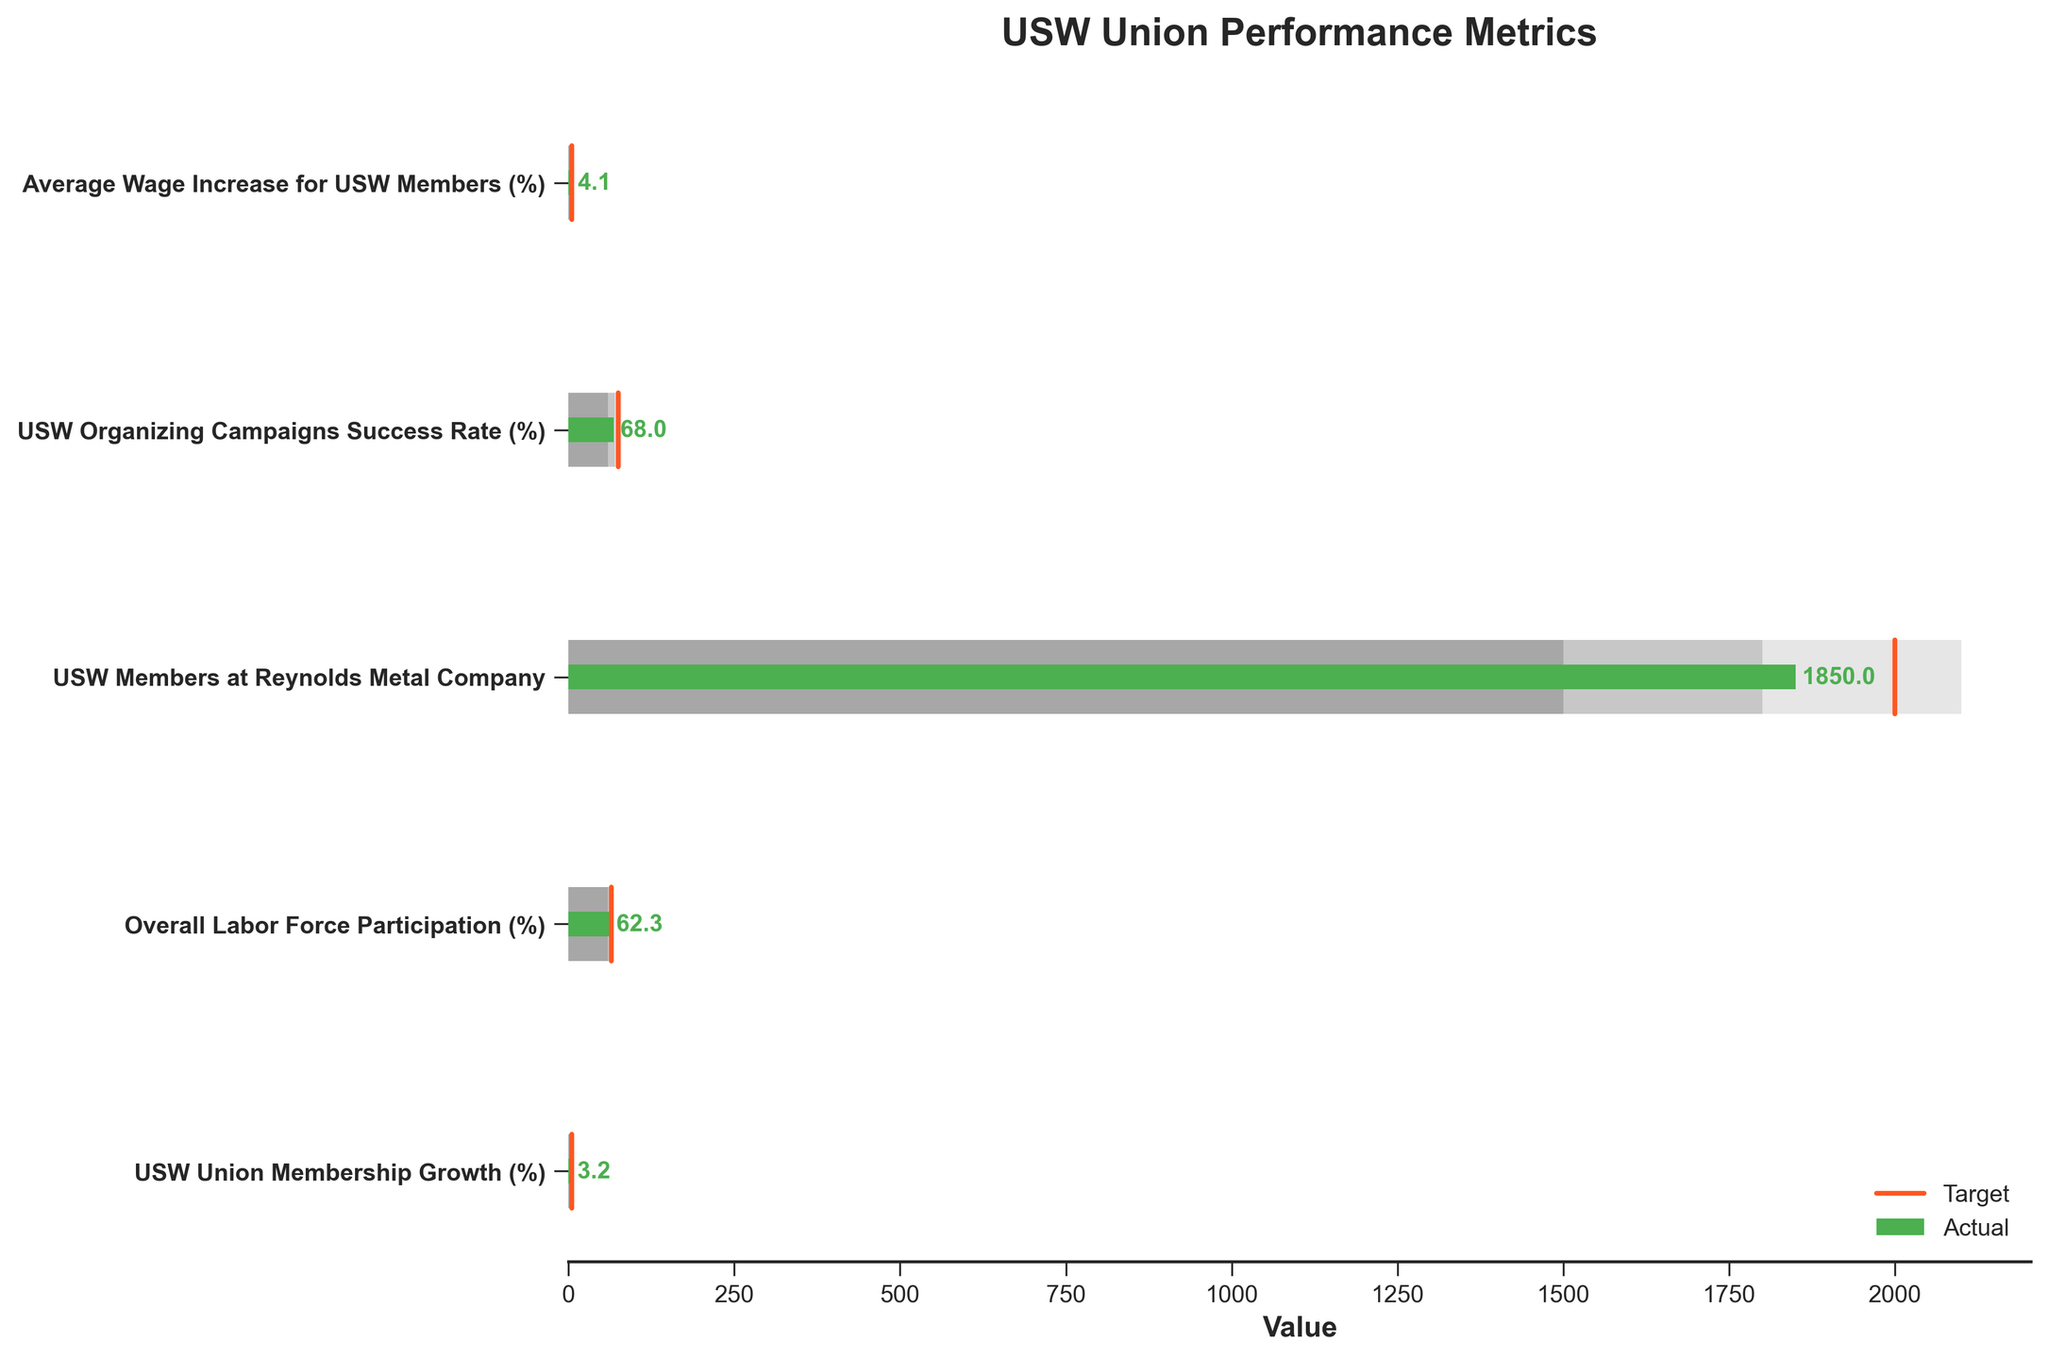What's the title of the figure? The title of the figure is displayed prominently at the top and reads "USW Union Performance Metrics".
Answer: USW Union Performance Metrics What's the actual growth percentage of USW union membership as shown in the chart? The actual growth percentage of USW union membership is shown by the green bar corresponding to the "USW Union Membership Growth (%)" category.
Answer: 3.2% What is the target value for the overall labor force participation rate? The target value is indicated by a red marker line on the horizontal bar corresponding to the "Overall Labor Force Participation (%)" category.
Answer: 65% What's the difference between the actual and target values for average wage increase for USW members? The actual value for average wage increase is shown as 4.1% and the target value is 5%. The difference is 5% - 4.1% = 0.9%.
Answer: 0.9% Which metric shows the smallest gap between the actual value and its target? To find the smallest gap, compare the differences between actual and target values for all metrics: USW Union Membership Growth (1.8), Overall Labor Force Participation (2.7), USW Members at Reynolds Metal Company (150), USW Organizing Campaigns Success Rate (7), and Average Wage Increase for USW Members (0.9). The smallest gap is 0.9 for Average Wage Increase.
Answer: Average Wage Increase for USW Members How does the USW Organizing Campaigns Success Rate compare to its optimal range (Range 3)? The USW Organizing Campaigns Success Rate is 68%, the optimal range starts at 70%, so it falls below by 2%.
Answer: falls below by 2% Are the actual values for any metrics higher than their target values? By examining the green bars and the red target markers, none of the actual values exceed their corresponding target values.
Answer: No What is the median value of the actual percentages listed in the figure? The actual values in percentages are: 3.2, 62.3, 68, and 4.1. Arrange them in ascending order: 3.2, 4.1, 62.3, 68. The median is the average of the middle two values: (4.1 + 62.3)/2 = 33.2.
Answer: 33.2 Among the metrics showing percentage values, which one has the closest actual percentage to its target? Calculate the absolute differences between actual and target percentages: USW Union Membership Growth (1.8%), Overall Labor Force Participation (2.7%), USW Organizing Campaigns Success Rate (7%), and Average Wage Increase (0.9%). The closest percentage difference is for Average Wage Increase with 0.9%.
Answer: Average Wage Increase for USW Members For which metric do the actual and target values have the highest percentage difference? Calculate the percentage difference relative to the target for each metric: 
- USW Union Membership Growth: (5 - 3.2)/5 = 36%
- Overall Labor Force Participation: (65 - 62.3)/65 = 4.15%
- USW Organizing Campaigns Success Rate: (75 - 68)/75 = 9.33%
- Average Wage Increase: (5 - 4.1)/5 = 18%
The highest percentage difference is for USW Union Membership Growth with 36%.
Answer: USW Union Membership Growth 